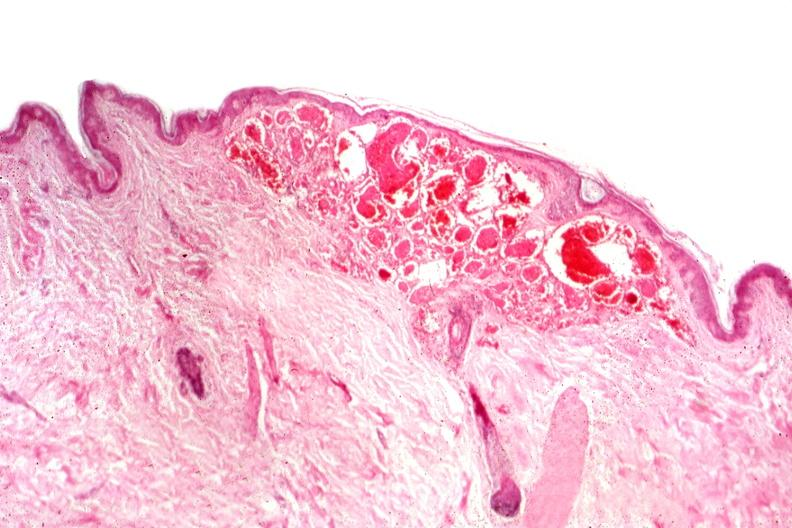where is this?
Answer the question using a single word or phrase. Skin 